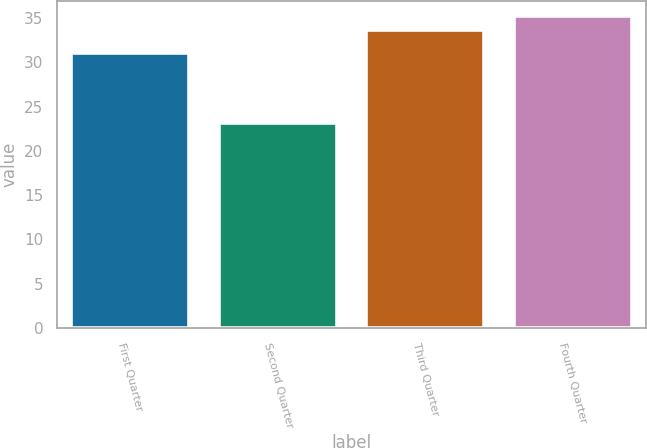Convert chart. <chart><loc_0><loc_0><loc_500><loc_500><bar_chart><fcel>First Quarter<fcel>Second Quarter<fcel>Third Quarter<fcel>Fourth Quarter<nl><fcel>31<fcel>23.16<fcel>33.67<fcel>35.21<nl></chart> 